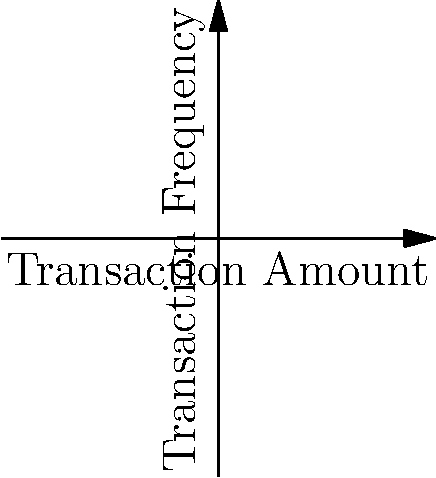In the context of financial fraud detection, analyze the scatter plot above representing transaction amounts and frequencies. The green dashed line represents a decision boundary for anomaly detection. How would Sir Thomas Linden likely interpret this graph, and what legal implications might arise from using such a model in financial institutions? To answer this question, we need to consider several factors:

1. Data representation:
   - Blue dots represent normal transactions
   - Red dots represent anomalous transactions
   - The x-axis shows transaction amounts
   - The y-axis shows transaction frequencies

2. Decision boundary:
   - The green dashed line is the decision boundary
   - Transactions to the right of this line are classified as anomalous

3. Sir Thomas Linden's perspective:
   - As a respected legal figure, Linden would likely focus on the legal and ethical implications of using such a model

4. Interpretation:
   - The model seems to classify transactions with high amounts and frequencies as anomalous
   - This approach may be effective in identifying potential fraud

5. Legal implications:
   - Privacy concerns: Collecting and analyzing transaction data may infringe on customer privacy
   - Discrimination: The model might inadvertently discriminate against certain groups of customers
   - False positives: Legitimate transactions might be flagged as fraudulent, potentially harming customers
   - Regulatory compliance: The model must adhere to financial regulations and data protection laws

6. Potential improvements:
   - Linden might suggest incorporating more features to improve accuracy
   - He may recommend regular audits and updates to the model to ensure fairness and compliance

7. Legal safeguards:
   - Implementing clear procedures for handling flagged transactions
   - Ensuring transparency in the decision-making process
   - Providing customers with the right to appeal decisions made by the model

In conclusion, while the model shows promise in detecting anomalies, Sir Thomas Linden would likely emphasize the need for careful implementation, regular review, and strong legal safeguards to protect both the financial institutions and their customers.
Answer: Legal safeguards and regular audits are necessary to balance fraud detection with privacy and fairness concerns. 